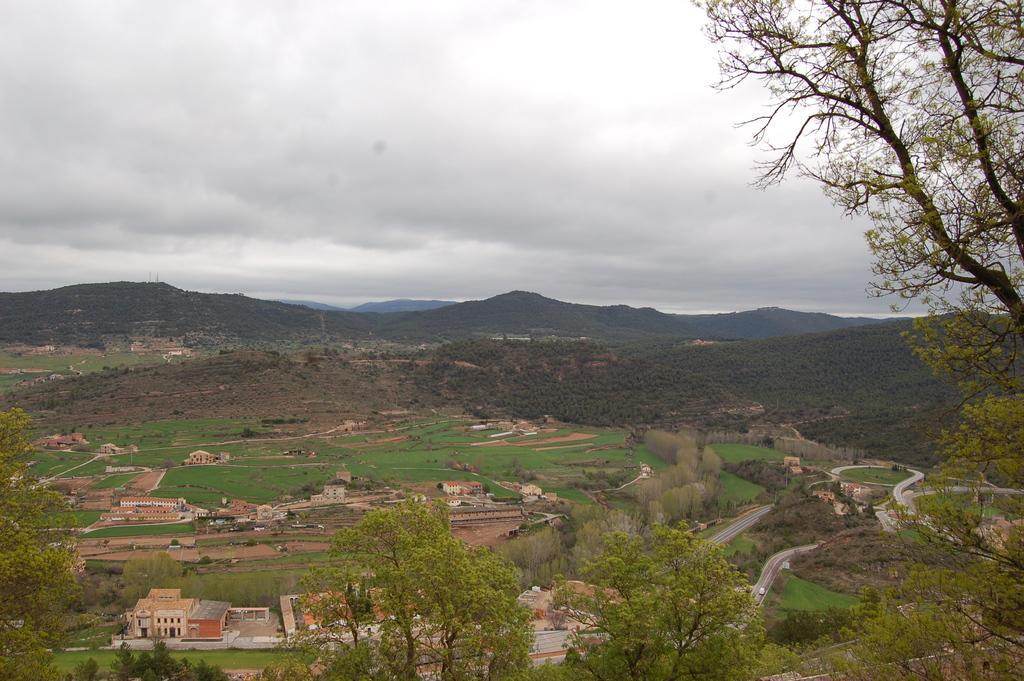Describe this image in one or two sentences. This is an aerial view. In this picture we can see the hills, trees, roads, buildings, grass. At the top of the image we can see the clouds in the sky. 